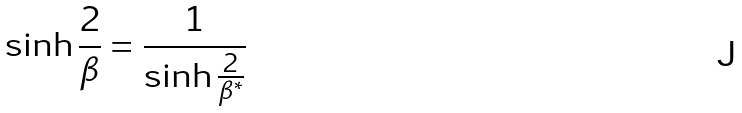Convert formula to latex. <formula><loc_0><loc_0><loc_500><loc_500>\sinh \frac { 2 } { \beta } = \frac { 1 } { \sinh \frac { 2 } { \beta ^ { * } } }</formula> 